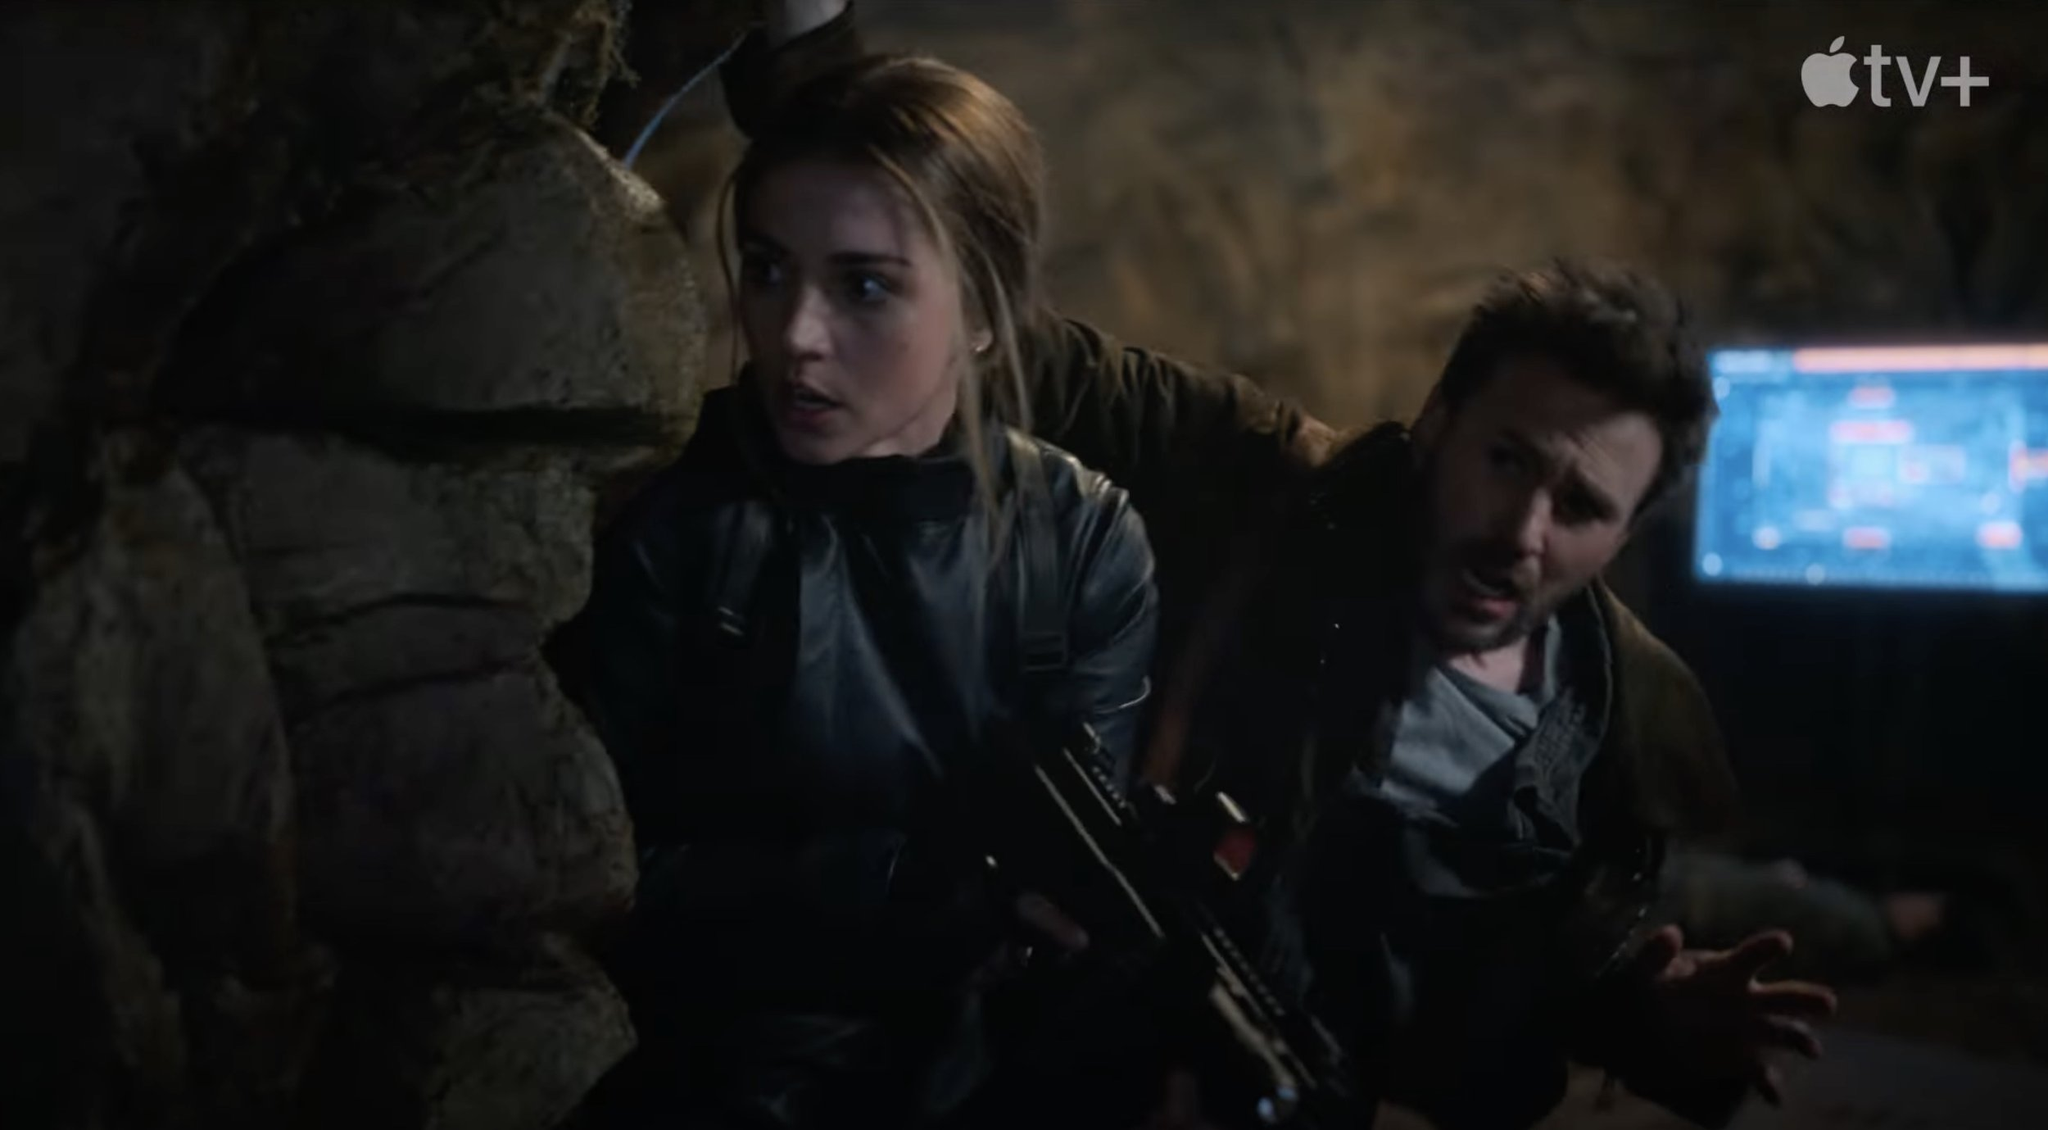What leads up to this decisive moment in the story? The characters have been pursuing a dangerous criminal organization that operates from the shadows. Their investigation led them through a maze of deceptive leads and perilous encounters. They deciphered hidden messages and infiltrated deep into enemy lines, only to discover that the organization's stronghold is within this cave. The computer screen in the background is their crucial link to their team, providing them with real-time intelligence. Everything they’ve done has led to this crucial moment where they must stop the enemies from executing their nefarious plans, risking their lives for the greater good. How does this scene exemplify the theme of courage? This scene is a powerful depiction of courage under fire. The characters are up against unknown odds in a forbidding environment. Their willingness to face potential doom head-on, armed and alert, showcases their bravery. The determination in their expressions, the readiness in their stances, and their calculated attentiveness in the face of danger all highlight their inner strength and resolve. This moment captures their unwavering commitment to their mission, even when the stakes are at their highest, embodying the essence of courage. 